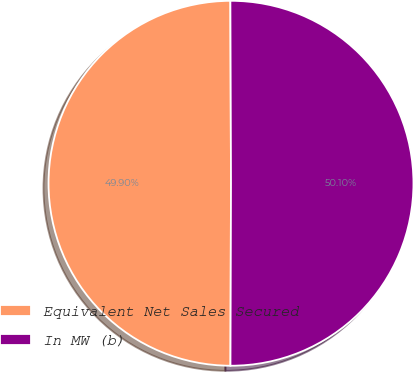Convert chart to OTSL. <chart><loc_0><loc_0><loc_500><loc_500><pie_chart><fcel>Equivalent Net Sales Secured<fcel>In MW (b)<nl><fcel>49.9%<fcel>50.1%<nl></chart> 